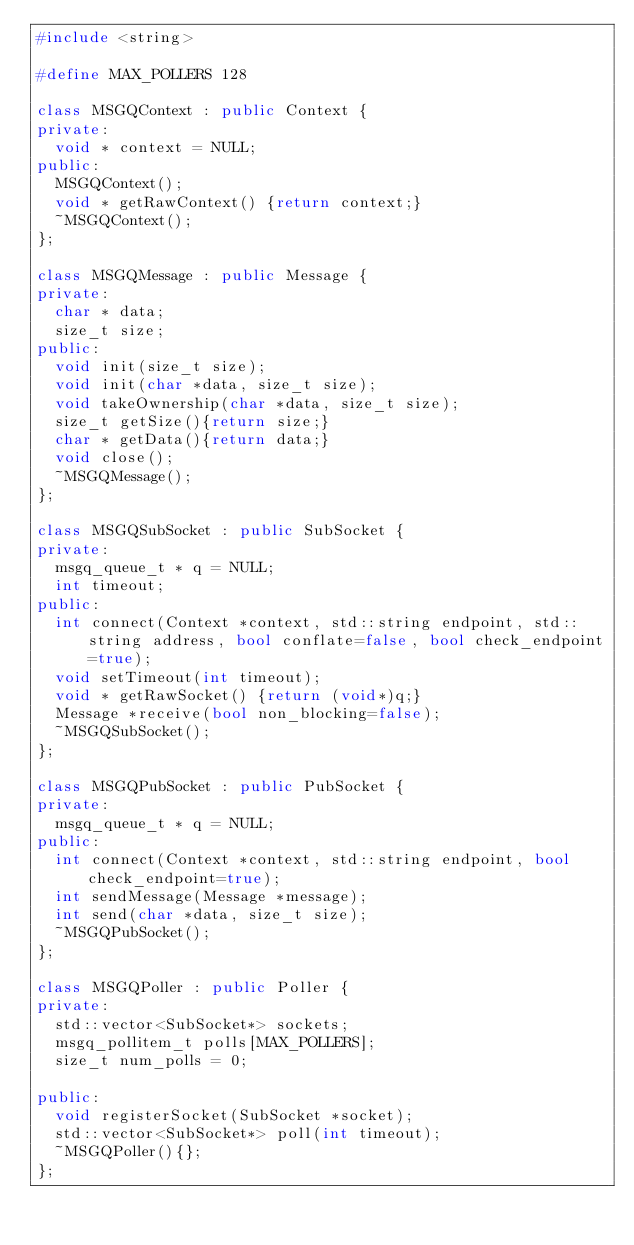Convert code to text. <code><loc_0><loc_0><loc_500><loc_500><_C++_>#include <string>

#define MAX_POLLERS 128

class MSGQContext : public Context {
private:
  void * context = NULL;
public:
  MSGQContext();
  void * getRawContext() {return context;}
  ~MSGQContext();
};

class MSGQMessage : public Message {
private:
  char * data;
  size_t size;
public:
  void init(size_t size);
  void init(char *data, size_t size);
  void takeOwnership(char *data, size_t size);
  size_t getSize(){return size;}
  char * getData(){return data;}
  void close();
  ~MSGQMessage();
};

class MSGQSubSocket : public SubSocket {
private:
  msgq_queue_t * q = NULL;
  int timeout;
public:
  int connect(Context *context, std::string endpoint, std::string address, bool conflate=false, bool check_endpoint=true);
  void setTimeout(int timeout);
  void * getRawSocket() {return (void*)q;}
  Message *receive(bool non_blocking=false);
  ~MSGQSubSocket();
};

class MSGQPubSocket : public PubSocket {
private:
  msgq_queue_t * q = NULL;
public:
  int connect(Context *context, std::string endpoint, bool check_endpoint=true);
  int sendMessage(Message *message);
  int send(char *data, size_t size);
  ~MSGQPubSocket();
};

class MSGQPoller : public Poller {
private:
  std::vector<SubSocket*> sockets;
  msgq_pollitem_t polls[MAX_POLLERS];
  size_t num_polls = 0;

public:
  void registerSocket(SubSocket *socket);
  std::vector<SubSocket*> poll(int timeout);
  ~MSGQPoller(){};
};
</code> 